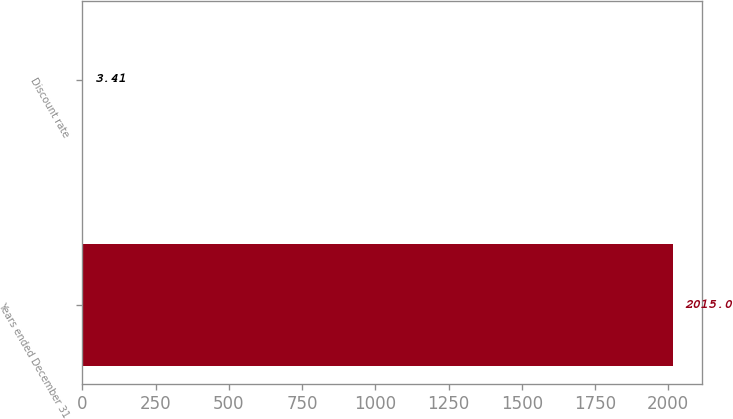Convert chart to OTSL. <chart><loc_0><loc_0><loc_500><loc_500><bar_chart><fcel>Years ended December 31<fcel>Discount rate<nl><fcel>2015<fcel>3.41<nl></chart> 